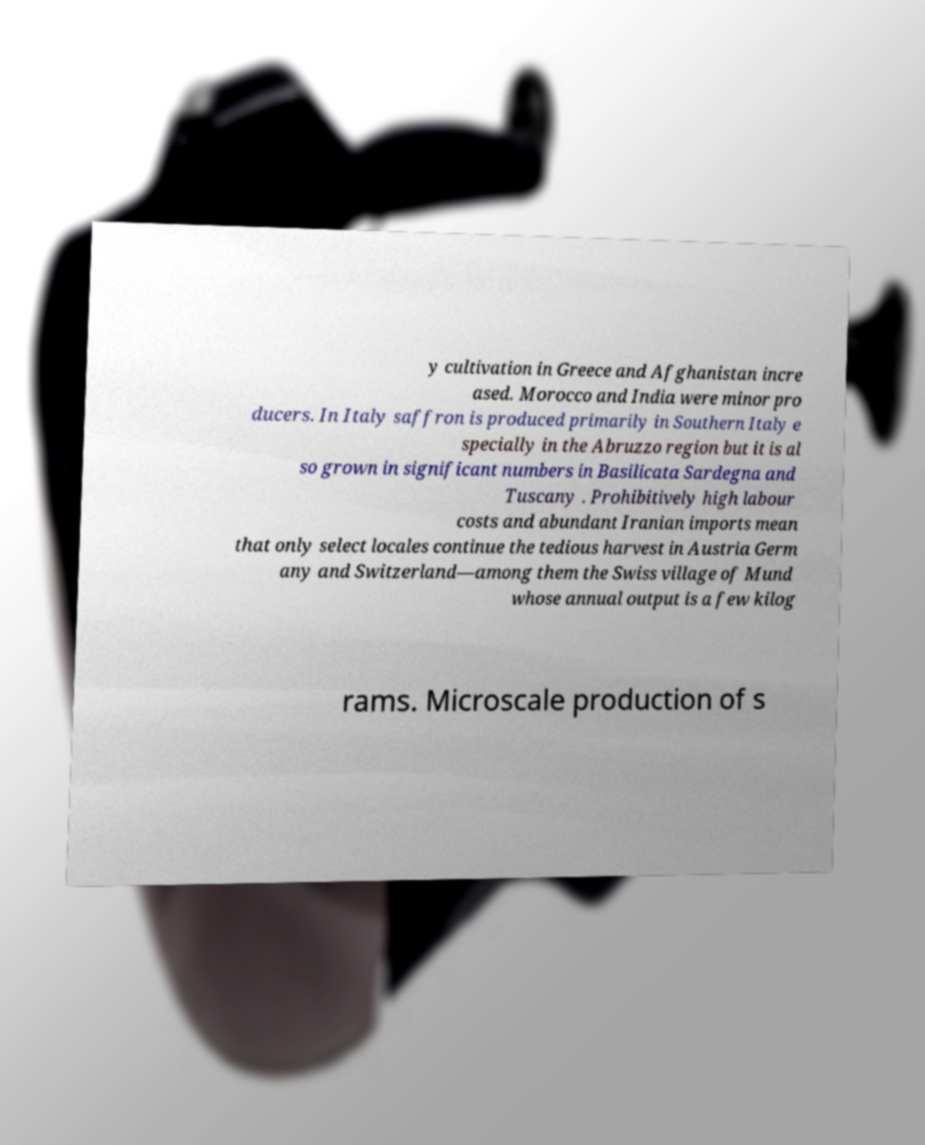Can you accurately transcribe the text from the provided image for me? y cultivation in Greece and Afghanistan incre ased. Morocco and India were minor pro ducers. In Italy saffron is produced primarily in Southern Italy e specially in the Abruzzo region but it is al so grown in significant numbers in Basilicata Sardegna and Tuscany . Prohibitively high labour costs and abundant Iranian imports mean that only select locales continue the tedious harvest in Austria Germ any and Switzerland—among them the Swiss village of Mund whose annual output is a few kilog rams. Microscale production of s 